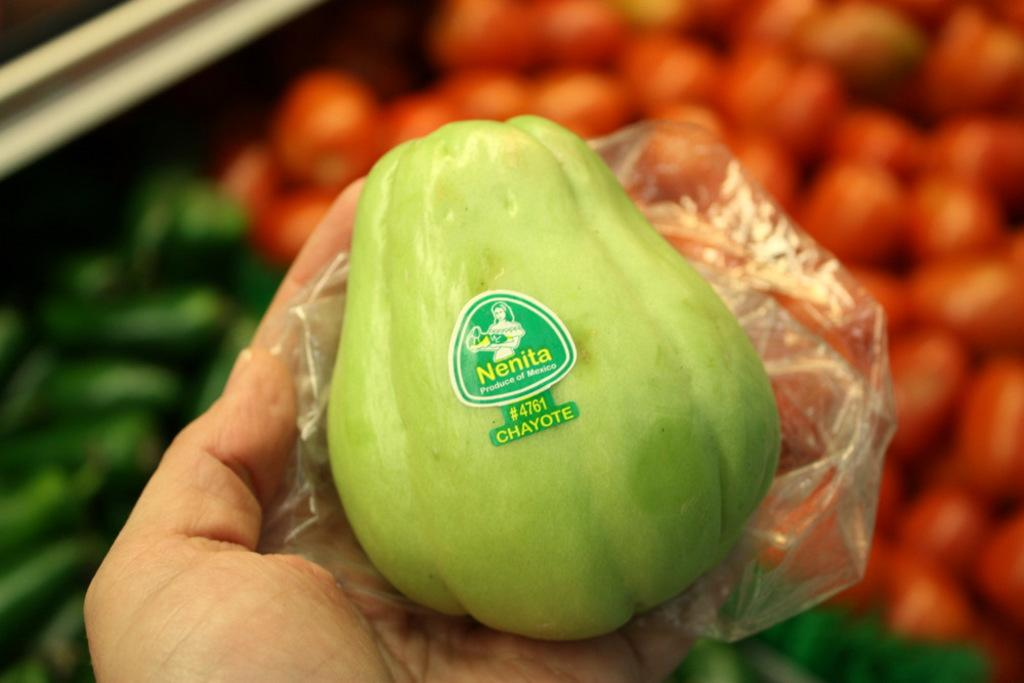What is the main subject of the image? There is a vegetable with a plastic cover in the image. How is the vegetable being held? The vegetable is on the palm of a person. Can you describe the background of the image? The background of the image is blurred. What colors are present in the image? There are red and green color things in the image. What is the name of the bone visible in the image? There is no bone visible in the image; it features a vegetable with a plastic cover being held by a person. 